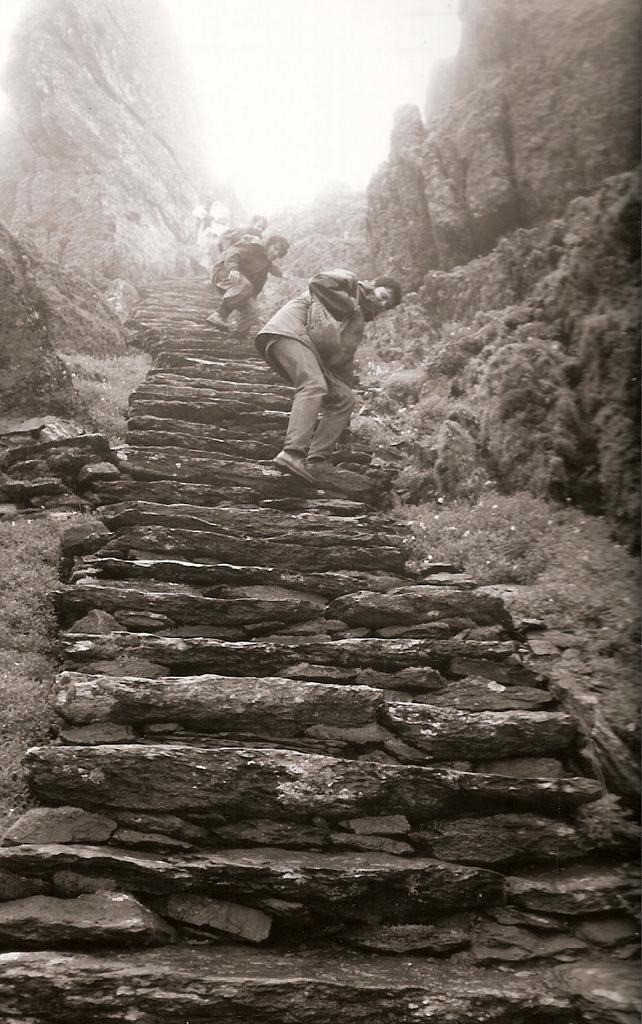What is the color scheme of the image? The image is black and white. What can be seen in the middle of the image? There are steps in the middle of the image. What are the people in the image doing? People are climbing the steps. What type of natural elements can be seen in the background of the image? There are many rocks in the background of the image. What type of sack can be seen being carried by the people in the image? There is no sack visible in the image; the people are simply climbing the steps. What emotion might the people in the image be feeling as they climb the steps? The image does not provide any information about the emotions of the people climbing the steps, so it cannot be determined. 